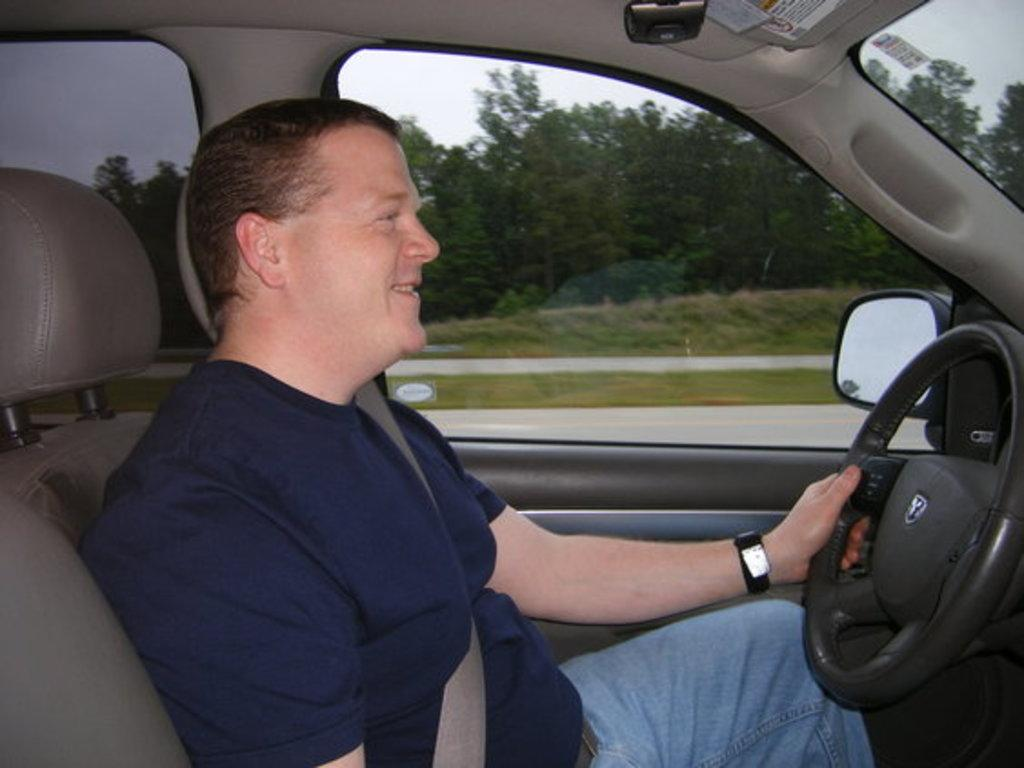Who is the main subject in the image? There is a man in the center of the image. What is the man's location in the image? The man is inside a car. What can be seen in the background of the image? There is greenery in the background of the image. What type of letter is the man holding in the image? There is no letter present in the image; the man is inside a car. How many birds can be seen flying in the image? There are no birds visible in the image; it features a man inside a car with greenery in the background. 